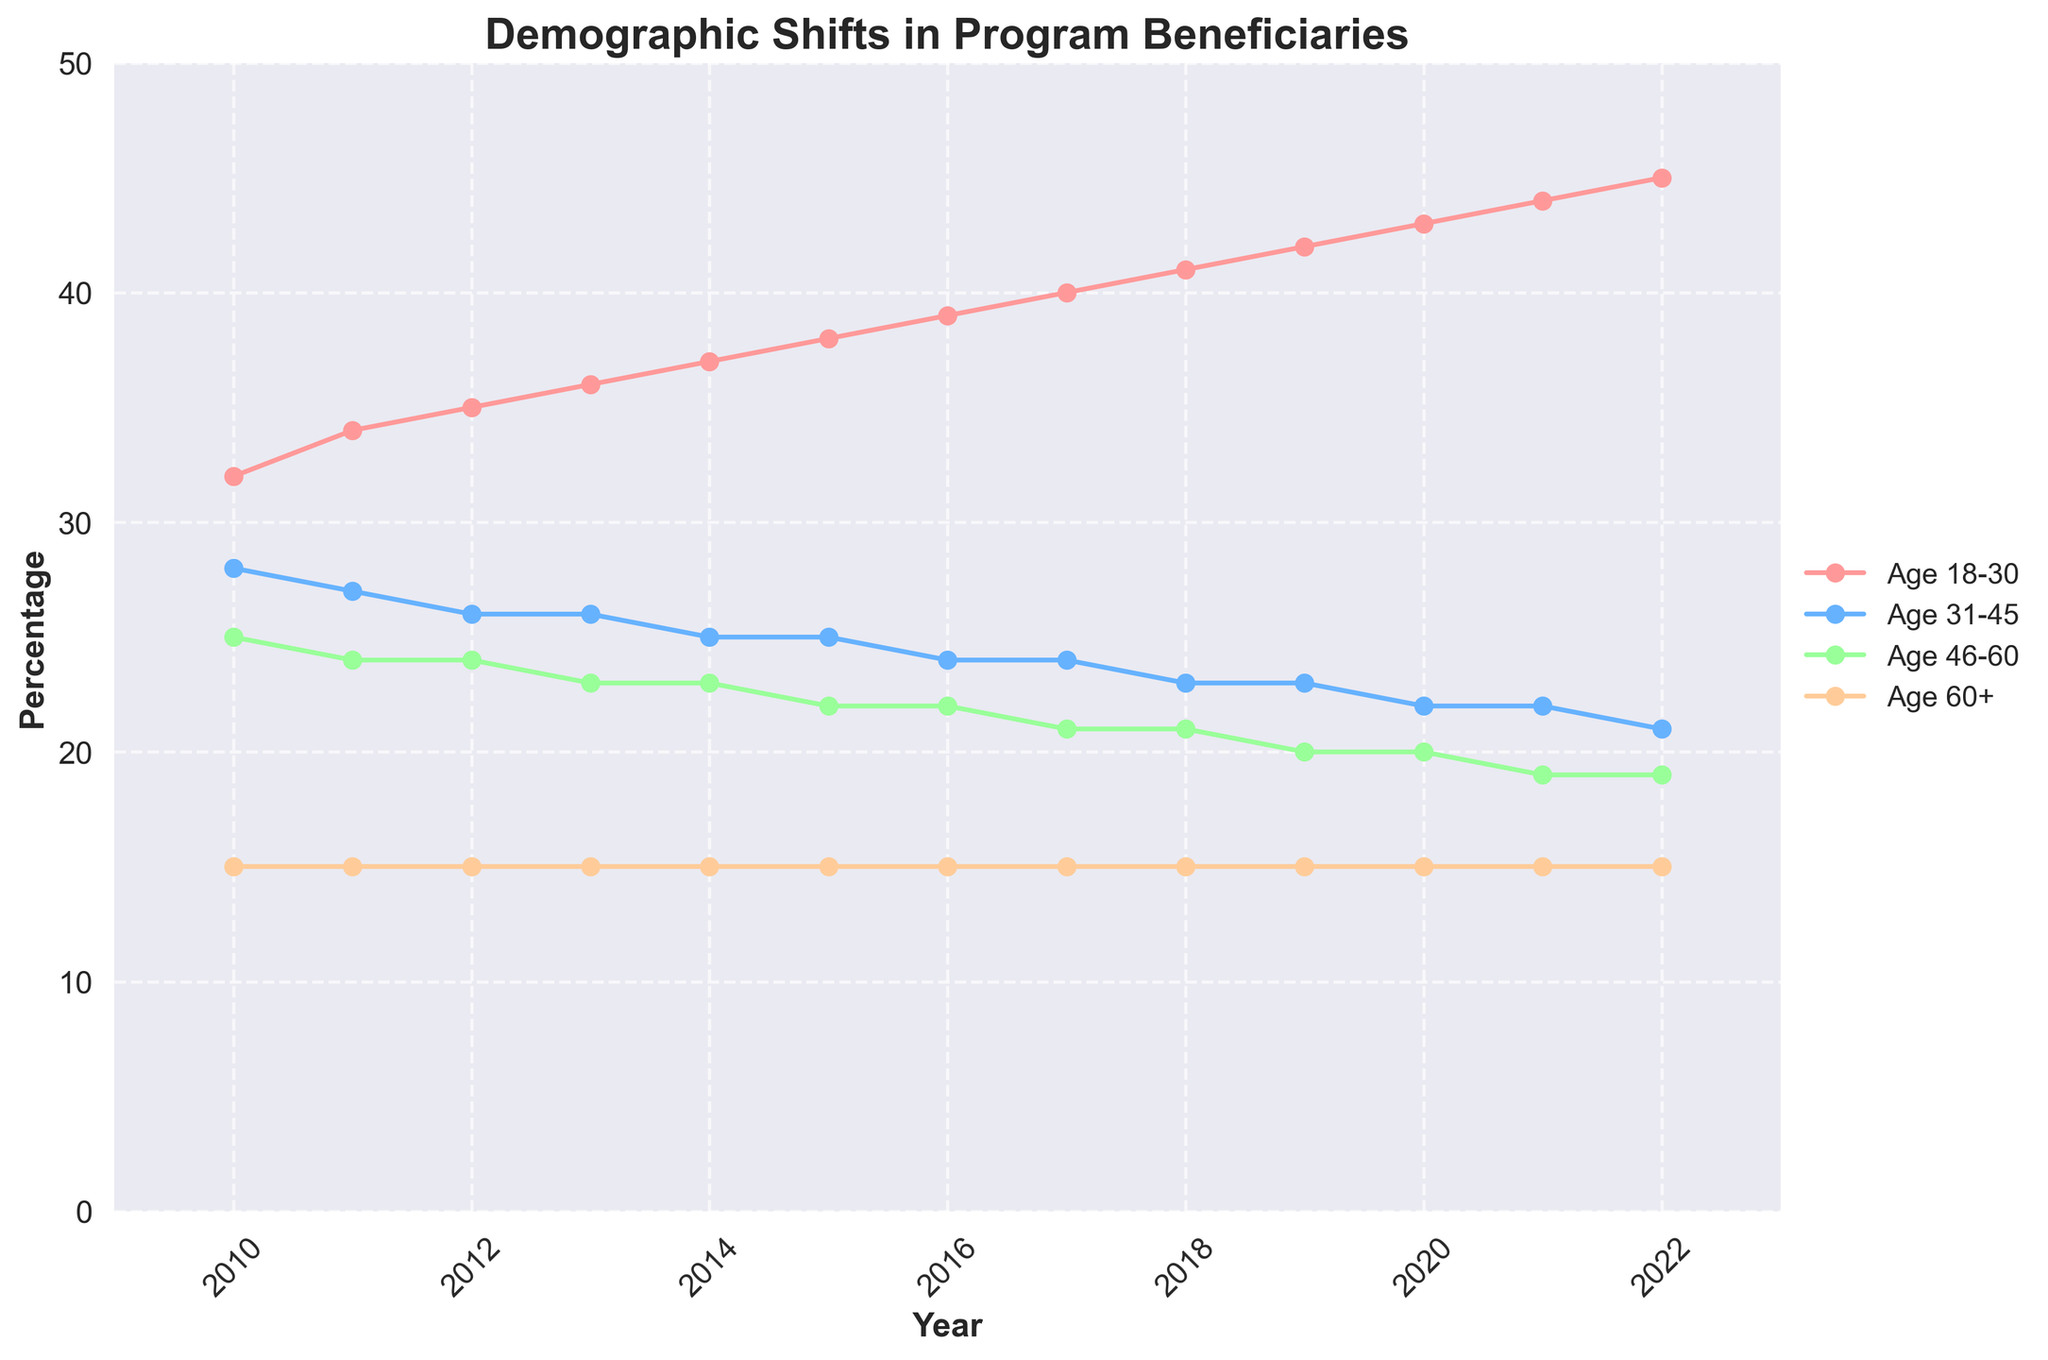What age group has the largest percentage in 2022? From the figure, locate the lines for 2022 and see which age group is highest. The 'Age 18-30' group is higher than others.
Answer: Age 18-30 How has the percentage of 'Low Income' beneficiaries changed from 2010 to 2022? Identify the 'Low Income' line and compare the values in 2010 and 2022. The percentage decreased from 60% in 2010 to 42% in 2022.
Answer: Decreased Between which years did the 'Female' beneficiary percentage remain constant? Visualize the 'Female' line and identify any segments where the curve is flat. The period between 2020 and 2021 shows no change.
Answer: 2020 and 2021 What is the difference in the percentage of 'Age 46-60' beneficiaries between 2012 and 2022? Locate the 'Age 46-60' line and calculate the difference between the points for the years 2012 (24%) and 2022 (19%). 24% - 19% is 5%.
Answer: 5% Which gender had a higher percentage of beneficiaries in 2020? Look at the lines for 'Female' and 'Male' in 2020. 'Female' has a percentage of 65%, while 'Male' has 35%.
Answer: Female In which year did 'Middle Income' beneficiaries first surpass 40%? Follow the 'Middle Income' line and identify the first year it goes above 40%. It first exceeds 40% in 2016.
Answer: 2016 What is the trend of 'Age 31-45' beneficiaries from 2010 to 2022? Observe the line for 'Age 31-45' from 2010 to 2022. The line shows a continuous decline over these years.
Answer: Declining Compare the percentage of 'High Income' beneficiaries in 2010 and 2022. Identify the points for 'High Income' in 2010 and 2022. In 2010 it is 5%, and in 2022, it is 10%. So, the percentage has increased.
Answer: Increased What is the sum of the percentages for 'Age 18-30' and 'Age 31-45' in 2018? Locate these points on the graph for 2018. Sum the percentages (41% for 'Age 18-30' and 23% for 'Age 31-45'). 41% + 23% = 64%.
Answer: 64% What colors represent the 'Age 31-45' and 'Age 60+' groups? From the legend, identify the colors for these groups. 'Age 31-45' is shaded blue, and 'Age 60+' is orange.
Answer: Blue and Orange 